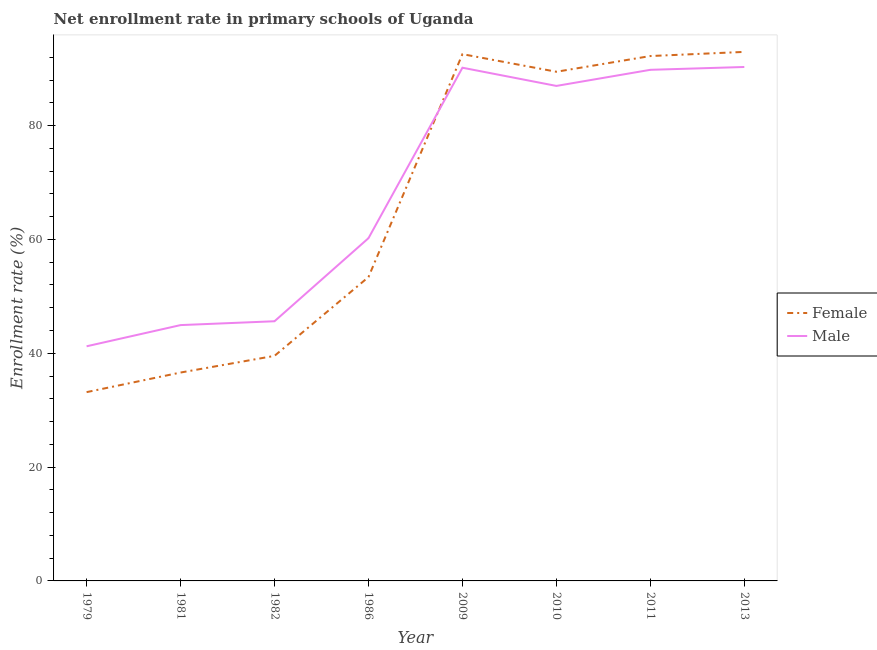Is the number of lines equal to the number of legend labels?
Your answer should be compact. Yes. What is the enrollment rate of female students in 1982?
Keep it short and to the point. 39.55. Across all years, what is the maximum enrollment rate of male students?
Offer a terse response. 90.31. Across all years, what is the minimum enrollment rate of male students?
Offer a very short reply. 41.23. In which year was the enrollment rate of male students minimum?
Ensure brevity in your answer.  1979. What is the total enrollment rate of female students in the graph?
Your response must be concise. 529.95. What is the difference between the enrollment rate of male students in 1981 and that in 1982?
Provide a short and direct response. -0.68. What is the difference between the enrollment rate of female students in 1981 and the enrollment rate of male students in 2010?
Ensure brevity in your answer.  -50.36. What is the average enrollment rate of female students per year?
Keep it short and to the point. 66.24. In the year 2010, what is the difference between the enrollment rate of male students and enrollment rate of female students?
Your answer should be very brief. -2.49. What is the ratio of the enrollment rate of male students in 1979 to that in 2011?
Your answer should be compact. 0.46. What is the difference between the highest and the second highest enrollment rate of male students?
Provide a short and direct response. 0.13. What is the difference between the highest and the lowest enrollment rate of female students?
Your answer should be compact. 59.79. Is the sum of the enrollment rate of female students in 1986 and 2009 greater than the maximum enrollment rate of male students across all years?
Ensure brevity in your answer.  Yes. Does the enrollment rate of female students monotonically increase over the years?
Give a very brief answer. No. Is the enrollment rate of male students strictly greater than the enrollment rate of female students over the years?
Offer a very short reply. No. Are the values on the major ticks of Y-axis written in scientific E-notation?
Make the answer very short. No. Does the graph contain any zero values?
Ensure brevity in your answer.  No. What is the title of the graph?
Your answer should be very brief. Net enrollment rate in primary schools of Uganda. Does "Death rate" appear as one of the legend labels in the graph?
Offer a terse response. No. What is the label or title of the X-axis?
Your answer should be very brief. Year. What is the label or title of the Y-axis?
Provide a succinct answer. Enrollment rate (%). What is the Enrollment rate (%) of Female in 1979?
Your answer should be very brief. 33.17. What is the Enrollment rate (%) of Male in 1979?
Your answer should be very brief. 41.23. What is the Enrollment rate (%) of Female in 1981?
Provide a succinct answer. 36.62. What is the Enrollment rate (%) of Male in 1981?
Offer a terse response. 44.95. What is the Enrollment rate (%) of Female in 1982?
Provide a short and direct response. 39.55. What is the Enrollment rate (%) in Male in 1982?
Provide a short and direct response. 45.63. What is the Enrollment rate (%) in Female in 1986?
Give a very brief answer. 53.39. What is the Enrollment rate (%) in Male in 1986?
Give a very brief answer. 60.22. What is the Enrollment rate (%) of Female in 2009?
Make the answer very short. 92.56. What is the Enrollment rate (%) in Male in 2009?
Your response must be concise. 90.18. What is the Enrollment rate (%) in Female in 2010?
Ensure brevity in your answer.  89.47. What is the Enrollment rate (%) of Male in 2010?
Make the answer very short. 86.98. What is the Enrollment rate (%) in Female in 2011?
Provide a succinct answer. 92.23. What is the Enrollment rate (%) in Male in 2011?
Offer a terse response. 89.81. What is the Enrollment rate (%) in Female in 2013?
Make the answer very short. 92.96. What is the Enrollment rate (%) of Male in 2013?
Make the answer very short. 90.31. Across all years, what is the maximum Enrollment rate (%) in Female?
Offer a very short reply. 92.96. Across all years, what is the maximum Enrollment rate (%) in Male?
Your answer should be compact. 90.31. Across all years, what is the minimum Enrollment rate (%) of Female?
Provide a succinct answer. 33.17. Across all years, what is the minimum Enrollment rate (%) of Male?
Your answer should be very brief. 41.23. What is the total Enrollment rate (%) of Female in the graph?
Ensure brevity in your answer.  529.95. What is the total Enrollment rate (%) in Male in the graph?
Ensure brevity in your answer.  549.3. What is the difference between the Enrollment rate (%) in Female in 1979 and that in 1981?
Offer a very short reply. -3.44. What is the difference between the Enrollment rate (%) in Male in 1979 and that in 1981?
Your answer should be compact. -3.72. What is the difference between the Enrollment rate (%) in Female in 1979 and that in 1982?
Provide a succinct answer. -6.37. What is the difference between the Enrollment rate (%) in Male in 1979 and that in 1982?
Provide a short and direct response. -4.4. What is the difference between the Enrollment rate (%) in Female in 1979 and that in 1986?
Provide a short and direct response. -20.22. What is the difference between the Enrollment rate (%) in Male in 1979 and that in 1986?
Give a very brief answer. -19. What is the difference between the Enrollment rate (%) of Female in 1979 and that in 2009?
Provide a succinct answer. -59.39. What is the difference between the Enrollment rate (%) of Male in 1979 and that in 2009?
Provide a succinct answer. -48.95. What is the difference between the Enrollment rate (%) in Female in 1979 and that in 2010?
Your response must be concise. -56.3. What is the difference between the Enrollment rate (%) of Male in 1979 and that in 2010?
Give a very brief answer. -45.75. What is the difference between the Enrollment rate (%) in Female in 1979 and that in 2011?
Provide a short and direct response. -59.06. What is the difference between the Enrollment rate (%) of Male in 1979 and that in 2011?
Your answer should be compact. -48.58. What is the difference between the Enrollment rate (%) in Female in 1979 and that in 2013?
Your response must be concise. -59.79. What is the difference between the Enrollment rate (%) in Male in 1979 and that in 2013?
Ensure brevity in your answer.  -49.08. What is the difference between the Enrollment rate (%) in Female in 1981 and that in 1982?
Give a very brief answer. -2.93. What is the difference between the Enrollment rate (%) in Male in 1981 and that in 1982?
Offer a terse response. -0.68. What is the difference between the Enrollment rate (%) of Female in 1981 and that in 1986?
Your answer should be very brief. -16.78. What is the difference between the Enrollment rate (%) in Male in 1981 and that in 1986?
Provide a short and direct response. -15.27. What is the difference between the Enrollment rate (%) of Female in 1981 and that in 2009?
Your answer should be compact. -55.95. What is the difference between the Enrollment rate (%) of Male in 1981 and that in 2009?
Your answer should be compact. -45.23. What is the difference between the Enrollment rate (%) of Female in 1981 and that in 2010?
Your answer should be compact. -52.85. What is the difference between the Enrollment rate (%) of Male in 1981 and that in 2010?
Give a very brief answer. -42.03. What is the difference between the Enrollment rate (%) of Female in 1981 and that in 2011?
Give a very brief answer. -55.61. What is the difference between the Enrollment rate (%) of Male in 1981 and that in 2011?
Make the answer very short. -44.86. What is the difference between the Enrollment rate (%) in Female in 1981 and that in 2013?
Make the answer very short. -56.34. What is the difference between the Enrollment rate (%) in Male in 1981 and that in 2013?
Offer a terse response. -45.35. What is the difference between the Enrollment rate (%) of Female in 1982 and that in 1986?
Your answer should be compact. -13.85. What is the difference between the Enrollment rate (%) in Male in 1982 and that in 1986?
Give a very brief answer. -14.6. What is the difference between the Enrollment rate (%) in Female in 1982 and that in 2009?
Your answer should be very brief. -53.02. What is the difference between the Enrollment rate (%) of Male in 1982 and that in 2009?
Provide a succinct answer. -44.55. What is the difference between the Enrollment rate (%) of Female in 1982 and that in 2010?
Offer a terse response. -49.92. What is the difference between the Enrollment rate (%) in Male in 1982 and that in 2010?
Offer a terse response. -41.35. What is the difference between the Enrollment rate (%) in Female in 1982 and that in 2011?
Your answer should be very brief. -52.68. What is the difference between the Enrollment rate (%) of Male in 1982 and that in 2011?
Offer a terse response. -44.18. What is the difference between the Enrollment rate (%) of Female in 1982 and that in 2013?
Provide a succinct answer. -53.41. What is the difference between the Enrollment rate (%) of Male in 1982 and that in 2013?
Keep it short and to the point. -44.68. What is the difference between the Enrollment rate (%) of Female in 1986 and that in 2009?
Ensure brevity in your answer.  -39.17. What is the difference between the Enrollment rate (%) in Male in 1986 and that in 2009?
Your answer should be compact. -29.95. What is the difference between the Enrollment rate (%) of Female in 1986 and that in 2010?
Ensure brevity in your answer.  -36.07. What is the difference between the Enrollment rate (%) of Male in 1986 and that in 2010?
Provide a short and direct response. -26.75. What is the difference between the Enrollment rate (%) in Female in 1986 and that in 2011?
Your answer should be compact. -38.84. What is the difference between the Enrollment rate (%) of Male in 1986 and that in 2011?
Ensure brevity in your answer.  -29.58. What is the difference between the Enrollment rate (%) in Female in 1986 and that in 2013?
Keep it short and to the point. -39.57. What is the difference between the Enrollment rate (%) in Male in 1986 and that in 2013?
Give a very brief answer. -30.08. What is the difference between the Enrollment rate (%) of Female in 2009 and that in 2010?
Give a very brief answer. 3.09. What is the difference between the Enrollment rate (%) in Male in 2009 and that in 2010?
Your answer should be compact. 3.2. What is the difference between the Enrollment rate (%) of Female in 2009 and that in 2011?
Your answer should be compact. 0.33. What is the difference between the Enrollment rate (%) of Male in 2009 and that in 2011?
Your answer should be compact. 0.37. What is the difference between the Enrollment rate (%) of Female in 2009 and that in 2013?
Your answer should be compact. -0.4. What is the difference between the Enrollment rate (%) in Male in 2009 and that in 2013?
Offer a very short reply. -0.13. What is the difference between the Enrollment rate (%) in Female in 2010 and that in 2011?
Give a very brief answer. -2.76. What is the difference between the Enrollment rate (%) in Male in 2010 and that in 2011?
Make the answer very short. -2.83. What is the difference between the Enrollment rate (%) of Female in 2010 and that in 2013?
Provide a succinct answer. -3.49. What is the difference between the Enrollment rate (%) in Male in 2010 and that in 2013?
Give a very brief answer. -3.33. What is the difference between the Enrollment rate (%) in Female in 2011 and that in 2013?
Your response must be concise. -0.73. What is the difference between the Enrollment rate (%) in Male in 2011 and that in 2013?
Give a very brief answer. -0.5. What is the difference between the Enrollment rate (%) of Female in 1979 and the Enrollment rate (%) of Male in 1981?
Provide a short and direct response. -11.78. What is the difference between the Enrollment rate (%) of Female in 1979 and the Enrollment rate (%) of Male in 1982?
Keep it short and to the point. -12.45. What is the difference between the Enrollment rate (%) of Female in 1979 and the Enrollment rate (%) of Male in 1986?
Offer a terse response. -27.05. What is the difference between the Enrollment rate (%) in Female in 1979 and the Enrollment rate (%) in Male in 2009?
Your answer should be very brief. -57. What is the difference between the Enrollment rate (%) of Female in 1979 and the Enrollment rate (%) of Male in 2010?
Your answer should be very brief. -53.81. What is the difference between the Enrollment rate (%) of Female in 1979 and the Enrollment rate (%) of Male in 2011?
Provide a short and direct response. -56.64. What is the difference between the Enrollment rate (%) in Female in 1979 and the Enrollment rate (%) in Male in 2013?
Your answer should be compact. -57.13. What is the difference between the Enrollment rate (%) of Female in 1981 and the Enrollment rate (%) of Male in 1982?
Provide a succinct answer. -9.01. What is the difference between the Enrollment rate (%) in Female in 1981 and the Enrollment rate (%) in Male in 1986?
Give a very brief answer. -23.61. What is the difference between the Enrollment rate (%) in Female in 1981 and the Enrollment rate (%) in Male in 2009?
Your answer should be compact. -53.56. What is the difference between the Enrollment rate (%) of Female in 1981 and the Enrollment rate (%) of Male in 2010?
Your response must be concise. -50.36. What is the difference between the Enrollment rate (%) of Female in 1981 and the Enrollment rate (%) of Male in 2011?
Provide a short and direct response. -53.19. What is the difference between the Enrollment rate (%) of Female in 1981 and the Enrollment rate (%) of Male in 2013?
Make the answer very short. -53.69. What is the difference between the Enrollment rate (%) in Female in 1982 and the Enrollment rate (%) in Male in 1986?
Provide a succinct answer. -20.68. What is the difference between the Enrollment rate (%) of Female in 1982 and the Enrollment rate (%) of Male in 2009?
Offer a very short reply. -50.63. What is the difference between the Enrollment rate (%) in Female in 1982 and the Enrollment rate (%) in Male in 2010?
Provide a succinct answer. -47.43. What is the difference between the Enrollment rate (%) of Female in 1982 and the Enrollment rate (%) of Male in 2011?
Offer a terse response. -50.26. What is the difference between the Enrollment rate (%) in Female in 1982 and the Enrollment rate (%) in Male in 2013?
Ensure brevity in your answer.  -50.76. What is the difference between the Enrollment rate (%) of Female in 1986 and the Enrollment rate (%) of Male in 2009?
Your answer should be compact. -36.78. What is the difference between the Enrollment rate (%) of Female in 1986 and the Enrollment rate (%) of Male in 2010?
Give a very brief answer. -33.59. What is the difference between the Enrollment rate (%) in Female in 1986 and the Enrollment rate (%) in Male in 2011?
Keep it short and to the point. -36.42. What is the difference between the Enrollment rate (%) in Female in 1986 and the Enrollment rate (%) in Male in 2013?
Keep it short and to the point. -36.91. What is the difference between the Enrollment rate (%) of Female in 2009 and the Enrollment rate (%) of Male in 2010?
Offer a terse response. 5.58. What is the difference between the Enrollment rate (%) in Female in 2009 and the Enrollment rate (%) in Male in 2011?
Provide a short and direct response. 2.75. What is the difference between the Enrollment rate (%) in Female in 2009 and the Enrollment rate (%) in Male in 2013?
Your answer should be very brief. 2.26. What is the difference between the Enrollment rate (%) in Female in 2010 and the Enrollment rate (%) in Male in 2011?
Make the answer very short. -0.34. What is the difference between the Enrollment rate (%) of Female in 2010 and the Enrollment rate (%) of Male in 2013?
Keep it short and to the point. -0.84. What is the difference between the Enrollment rate (%) in Female in 2011 and the Enrollment rate (%) in Male in 2013?
Provide a short and direct response. 1.92. What is the average Enrollment rate (%) in Female per year?
Give a very brief answer. 66.24. What is the average Enrollment rate (%) of Male per year?
Provide a succinct answer. 68.66. In the year 1979, what is the difference between the Enrollment rate (%) in Female and Enrollment rate (%) in Male?
Offer a terse response. -8.05. In the year 1981, what is the difference between the Enrollment rate (%) in Female and Enrollment rate (%) in Male?
Your response must be concise. -8.34. In the year 1982, what is the difference between the Enrollment rate (%) in Female and Enrollment rate (%) in Male?
Offer a very short reply. -6.08. In the year 1986, what is the difference between the Enrollment rate (%) in Female and Enrollment rate (%) in Male?
Provide a succinct answer. -6.83. In the year 2009, what is the difference between the Enrollment rate (%) of Female and Enrollment rate (%) of Male?
Provide a short and direct response. 2.38. In the year 2010, what is the difference between the Enrollment rate (%) of Female and Enrollment rate (%) of Male?
Provide a succinct answer. 2.49. In the year 2011, what is the difference between the Enrollment rate (%) of Female and Enrollment rate (%) of Male?
Give a very brief answer. 2.42. In the year 2013, what is the difference between the Enrollment rate (%) of Female and Enrollment rate (%) of Male?
Make the answer very short. 2.65. What is the ratio of the Enrollment rate (%) of Female in 1979 to that in 1981?
Provide a short and direct response. 0.91. What is the ratio of the Enrollment rate (%) of Male in 1979 to that in 1981?
Your answer should be very brief. 0.92. What is the ratio of the Enrollment rate (%) in Female in 1979 to that in 1982?
Your response must be concise. 0.84. What is the ratio of the Enrollment rate (%) in Male in 1979 to that in 1982?
Make the answer very short. 0.9. What is the ratio of the Enrollment rate (%) in Female in 1979 to that in 1986?
Keep it short and to the point. 0.62. What is the ratio of the Enrollment rate (%) in Male in 1979 to that in 1986?
Your answer should be very brief. 0.68. What is the ratio of the Enrollment rate (%) of Female in 1979 to that in 2009?
Your response must be concise. 0.36. What is the ratio of the Enrollment rate (%) of Male in 1979 to that in 2009?
Offer a very short reply. 0.46. What is the ratio of the Enrollment rate (%) in Female in 1979 to that in 2010?
Offer a very short reply. 0.37. What is the ratio of the Enrollment rate (%) of Male in 1979 to that in 2010?
Provide a short and direct response. 0.47. What is the ratio of the Enrollment rate (%) of Female in 1979 to that in 2011?
Your response must be concise. 0.36. What is the ratio of the Enrollment rate (%) in Male in 1979 to that in 2011?
Your answer should be compact. 0.46. What is the ratio of the Enrollment rate (%) in Female in 1979 to that in 2013?
Make the answer very short. 0.36. What is the ratio of the Enrollment rate (%) of Male in 1979 to that in 2013?
Ensure brevity in your answer.  0.46. What is the ratio of the Enrollment rate (%) in Female in 1981 to that in 1982?
Your answer should be compact. 0.93. What is the ratio of the Enrollment rate (%) in Male in 1981 to that in 1982?
Make the answer very short. 0.99. What is the ratio of the Enrollment rate (%) in Female in 1981 to that in 1986?
Your response must be concise. 0.69. What is the ratio of the Enrollment rate (%) of Male in 1981 to that in 1986?
Your response must be concise. 0.75. What is the ratio of the Enrollment rate (%) of Female in 1981 to that in 2009?
Ensure brevity in your answer.  0.4. What is the ratio of the Enrollment rate (%) of Male in 1981 to that in 2009?
Make the answer very short. 0.5. What is the ratio of the Enrollment rate (%) in Female in 1981 to that in 2010?
Keep it short and to the point. 0.41. What is the ratio of the Enrollment rate (%) in Male in 1981 to that in 2010?
Offer a terse response. 0.52. What is the ratio of the Enrollment rate (%) of Female in 1981 to that in 2011?
Your answer should be very brief. 0.4. What is the ratio of the Enrollment rate (%) of Male in 1981 to that in 2011?
Ensure brevity in your answer.  0.5. What is the ratio of the Enrollment rate (%) of Female in 1981 to that in 2013?
Your answer should be very brief. 0.39. What is the ratio of the Enrollment rate (%) of Male in 1981 to that in 2013?
Offer a very short reply. 0.5. What is the ratio of the Enrollment rate (%) in Female in 1982 to that in 1986?
Your answer should be very brief. 0.74. What is the ratio of the Enrollment rate (%) of Male in 1982 to that in 1986?
Keep it short and to the point. 0.76. What is the ratio of the Enrollment rate (%) of Female in 1982 to that in 2009?
Keep it short and to the point. 0.43. What is the ratio of the Enrollment rate (%) of Male in 1982 to that in 2009?
Your answer should be compact. 0.51. What is the ratio of the Enrollment rate (%) in Female in 1982 to that in 2010?
Ensure brevity in your answer.  0.44. What is the ratio of the Enrollment rate (%) in Male in 1982 to that in 2010?
Offer a very short reply. 0.52. What is the ratio of the Enrollment rate (%) of Female in 1982 to that in 2011?
Your response must be concise. 0.43. What is the ratio of the Enrollment rate (%) of Male in 1982 to that in 2011?
Your response must be concise. 0.51. What is the ratio of the Enrollment rate (%) in Female in 1982 to that in 2013?
Provide a short and direct response. 0.43. What is the ratio of the Enrollment rate (%) of Male in 1982 to that in 2013?
Your answer should be very brief. 0.51. What is the ratio of the Enrollment rate (%) of Female in 1986 to that in 2009?
Offer a very short reply. 0.58. What is the ratio of the Enrollment rate (%) of Male in 1986 to that in 2009?
Offer a very short reply. 0.67. What is the ratio of the Enrollment rate (%) in Female in 1986 to that in 2010?
Your answer should be very brief. 0.6. What is the ratio of the Enrollment rate (%) of Male in 1986 to that in 2010?
Give a very brief answer. 0.69. What is the ratio of the Enrollment rate (%) in Female in 1986 to that in 2011?
Keep it short and to the point. 0.58. What is the ratio of the Enrollment rate (%) of Male in 1986 to that in 2011?
Make the answer very short. 0.67. What is the ratio of the Enrollment rate (%) of Female in 1986 to that in 2013?
Offer a very short reply. 0.57. What is the ratio of the Enrollment rate (%) in Male in 1986 to that in 2013?
Your response must be concise. 0.67. What is the ratio of the Enrollment rate (%) in Female in 2009 to that in 2010?
Provide a short and direct response. 1.03. What is the ratio of the Enrollment rate (%) of Male in 2009 to that in 2010?
Give a very brief answer. 1.04. What is the ratio of the Enrollment rate (%) in Female in 2009 to that in 2011?
Give a very brief answer. 1. What is the ratio of the Enrollment rate (%) in Female in 2009 to that in 2013?
Your answer should be very brief. 1. What is the ratio of the Enrollment rate (%) of Female in 2010 to that in 2011?
Offer a very short reply. 0.97. What is the ratio of the Enrollment rate (%) in Male in 2010 to that in 2011?
Provide a short and direct response. 0.97. What is the ratio of the Enrollment rate (%) of Female in 2010 to that in 2013?
Offer a terse response. 0.96. What is the ratio of the Enrollment rate (%) in Male in 2010 to that in 2013?
Make the answer very short. 0.96. What is the ratio of the Enrollment rate (%) in Female in 2011 to that in 2013?
Make the answer very short. 0.99. What is the difference between the highest and the second highest Enrollment rate (%) in Female?
Ensure brevity in your answer.  0.4. What is the difference between the highest and the second highest Enrollment rate (%) in Male?
Provide a short and direct response. 0.13. What is the difference between the highest and the lowest Enrollment rate (%) in Female?
Ensure brevity in your answer.  59.79. What is the difference between the highest and the lowest Enrollment rate (%) of Male?
Your answer should be very brief. 49.08. 